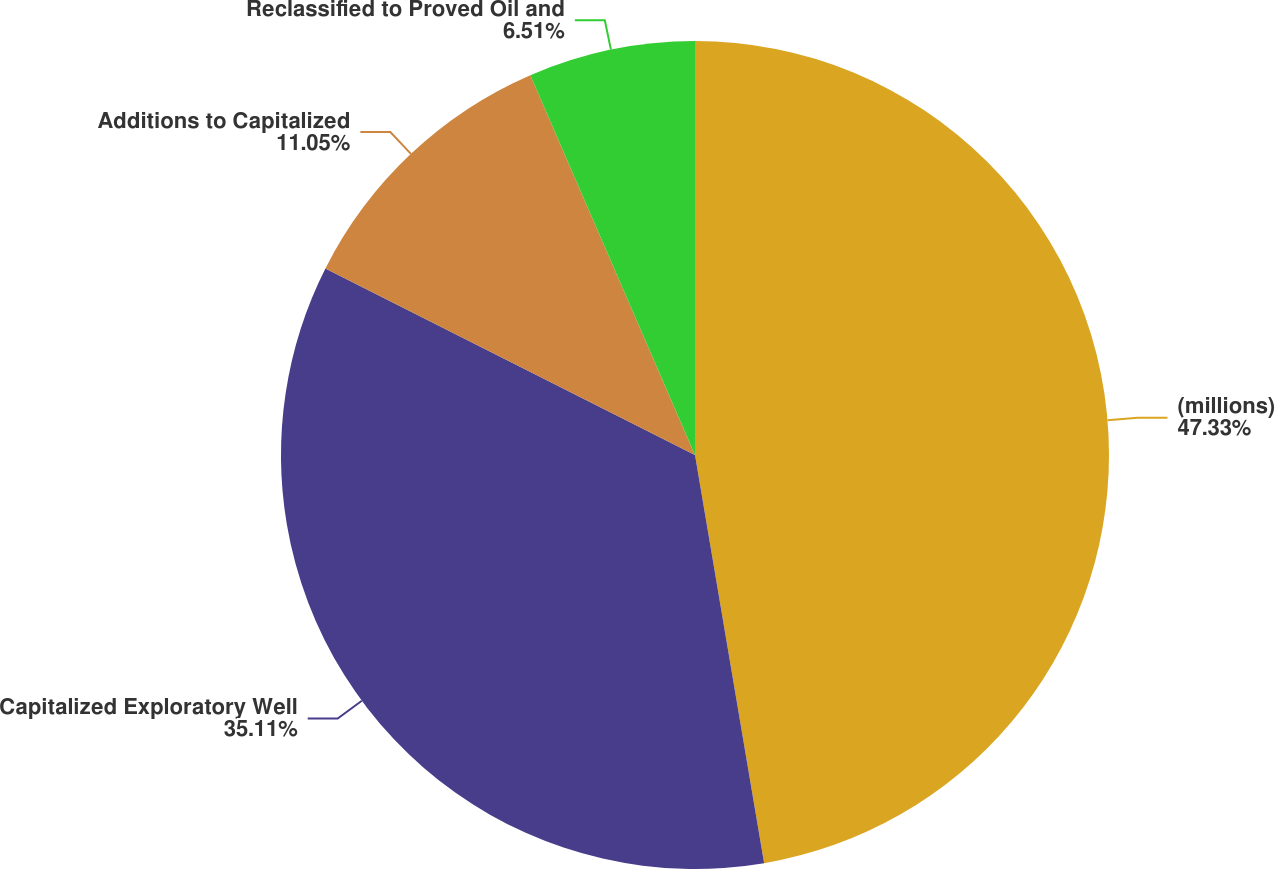Convert chart. <chart><loc_0><loc_0><loc_500><loc_500><pie_chart><fcel>(millions)<fcel>Capitalized Exploratory Well<fcel>Additions to Capitalized<fcel>Reclassified to Proved Oil and<nl><fcel>47.33%<fcel>35.11%<fcel>11.05%<fcel>6.51%<nl></chart> 